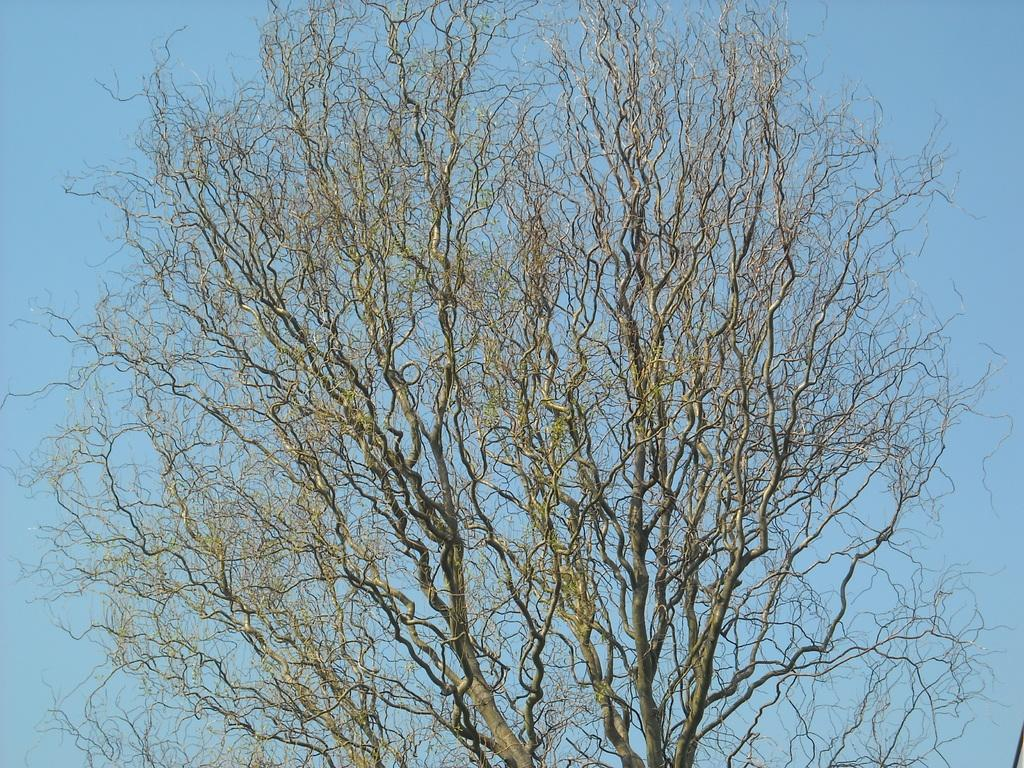What type of tree is in the image? There is a dry tree in the image. What is the color of the sky in the image? The sky is blue in the image. How does the tree help people in the image? The tree does not help people in the image, as it is a dry tree. What type of hair can be seen on the tree in the image? There is no hair present on the tree in the image, as it is a tree and not a living being with hair. 